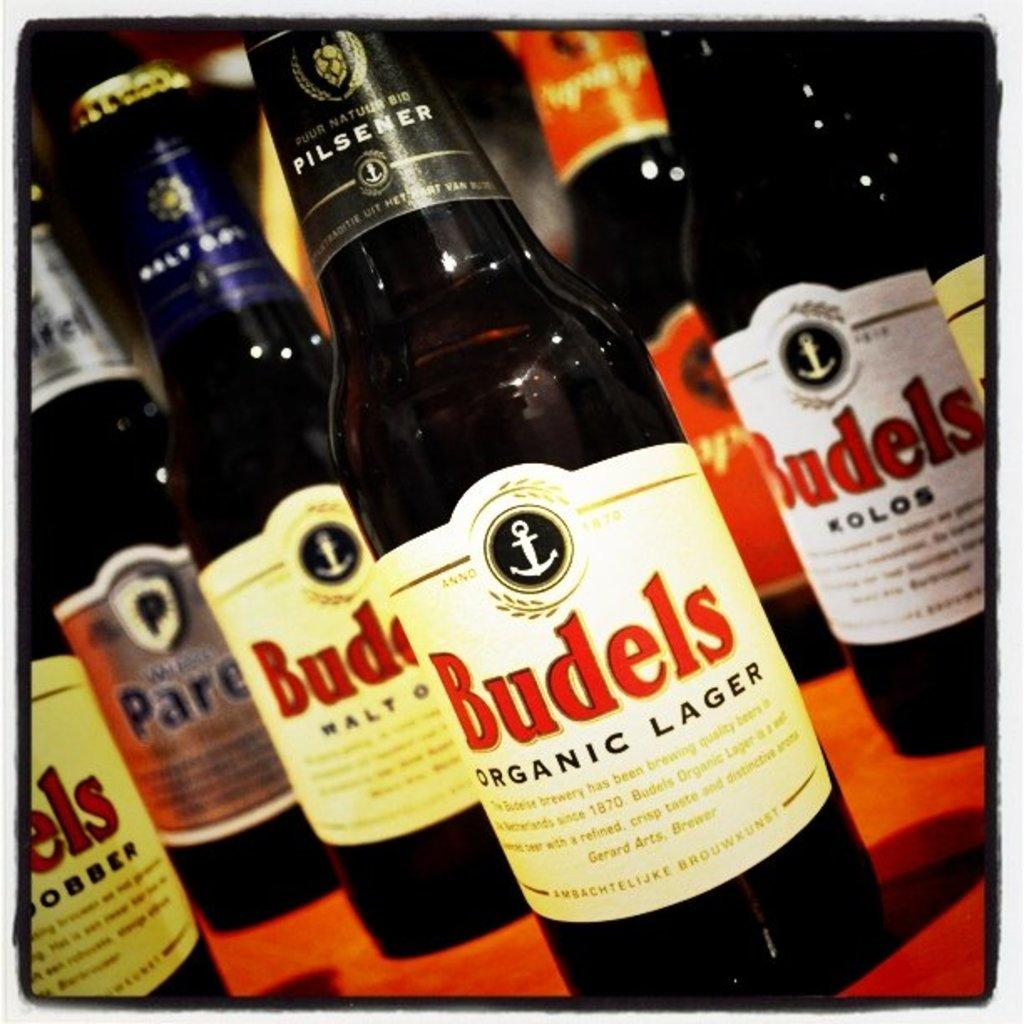<image>
Render a clear and concise summary of the photo. Bottles of Budels Lager are placed together on a red table. 